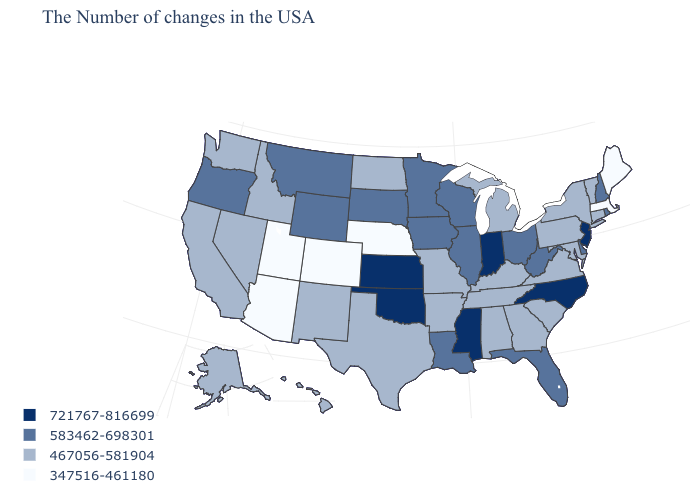What is the value of Maine?
Be succinct. 347516-461180. What is the value of Vermont?
Be succinct. 467056-581904. Does Kansas have the highest value in the USA?
Concise answer only. Yes. Which states have the lowest value in the USA?
Answer briefly. Maine, Massachusetts, Nebraska, Colorado, Utah, Arizona. What is the value of Massachusetts?
Concise answer only. 347516-461180. What is the value of Wyoming?
Be succinct. 583462-698301. What is the highest value in states that border Tennessee?
Answer briefly. 721767-816699. What is the highest value in states that border Texas?
Quick response, please. 721767-816699. What is the value of Virginia?
Concise answer only. 467056-581904. What is the highest value in states that border Nevada?
Concise answer only. 583462-698301. Does Georgia have the highest value in the USA?
Short answer required. No. Does the map have missing data?
Keep it brief. No. Name the states that have a value in the range 467056-581904?
Concise answer only. Vermont, Connecticut, New York, Maryland, Pennsylvania, Virginia, South Carolina, Georgia, Michigan, Kentucky, Alabama, Tennessee, Missouri, Arkansas, Texas, North Dakota, New Mexico, Idaho, Nevada, California, Washington, Alaska, Hawaii. Which states have the lowest value in the USA?
Keep it brief. Maine, Massachusetts, Nebraska, Colorado, Utah, Arizona. Does the first symbol in the legend represent the smallest category?
Short answer required. No. 